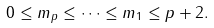<formula> <loc_0><loc_0><loc_500><loc_500>0 \leq m _ { p } \leq \dots \leq m _ { 1 } \leq p + 2 .</formula> 